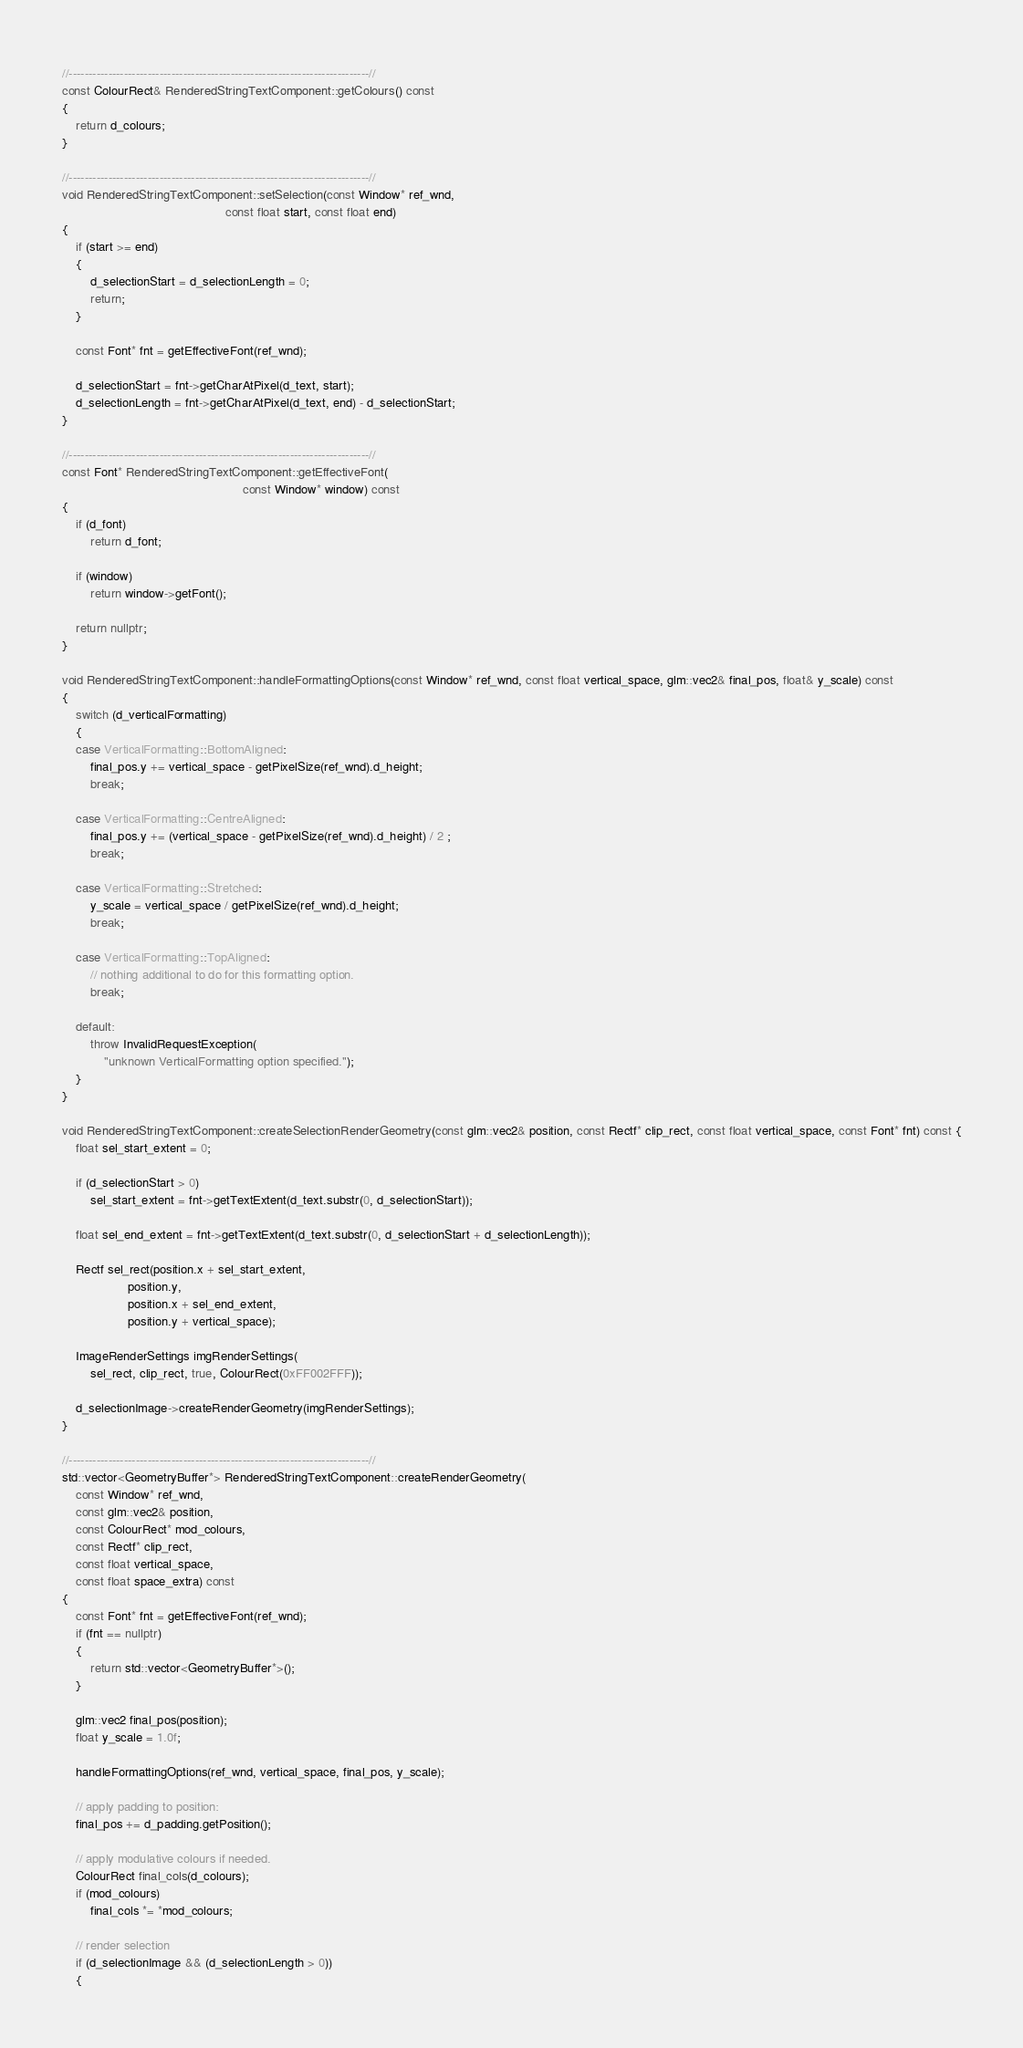Convert code to text. <code><loc_0><loc_0><loc_500><loc_500><_C++_>//----------------------------------------------------------------------------//
const ColourRect& RenderedStringTextComponent::getColours() const
{
    return d_colours;
}

//----------------------------------------------------------------------------//
void RenderedStringTextComponent::setSelection(const Window* ref_wnd,
                                               const float start, const float end)
{
    if (start >= end)
    {
        d_selectionStart = d_selectionLength = 0;
        return;
    }

    const Font* fnt = getEffectiveFont(ref_wnd);

    d_selectionStart = fnt->getCharAtPixel(d_text, start);
    d_selectionLength = fnt->getCharAtPixel(d_text, end) - d_selectionStart;
}

//----------------------------------------------------------------------------//
const Font* RenderedStringTextComponent::getEffectiveFont(
                                                    const Window* window) const
{
    if (d_font)
        return d_font;

    if (window)
        return window->getFont();

    return nullptr;
}

void RenderedStringTextComponent::handleFormattingOptions(const Window* ref_wnd, const float vertical_space, glm::vec2& final_pos, float& y_scale) const
{
    switch (d_verticalFormatting)
    {
    case VerticalFormatting::BottomAligned:
        final_pos.y += vertical_space - getPixelSize(ref_wnd).d_height;
        break;

    case VerticalFormatting::CentreAligned:
        final_pos.y += (vertical_space - getPixelSize(ref_wnd).d_height) / 2 ;
        break;

    case VerticalFormatting::Stretched:
        y_scale = vertical_space / getPixelSize(ref_wnd).d_height;
        break;

    case VerticalFormatting::TopAligned:
        // nothing additional to do for this formatting option.
        break;

    default:
        throw InvalidRequestException(
            "unknown VerticalFormatting option specified.");
    }
}

void RenderedStringTextComponent::createSelectionRenderGeometry(const glm::vec2& position, const Rectf* clip_rect, const float vertical_space, const Font* fnt) const {
    float sel_start_extent = 0;

    if (d_selectionStart > 0)
        sel_start_extent = fnt->getTextExtent(d_text.substr(0, d_selectionStart));

    float sel_end_extent = fnt->getTextExtent(d_text.substr(0, d_selectionStart + d_selectionLength));

    Rectf sel_rect(position.x + sel_start_extent,
                   position.y,
                   position.x + sel_end_extent,
                   position.y + vertical_space);

    ImageRenderSettings imgRenderSettings(
        sel_rect, clip_rect, true, ColourRect(0xFF002FFF));

    d_selectionImage->createRenderGeometry(imgRenderSettings);
}

//----------------------------------------------------------------------------//
std::vector<GeometryBuffer*> RenderedStringTextComponent::createRenderGeometry(
    const Window* ref_wnd,
    const glm::vec2& position,
    const ColourRect* mod_colours,
    const Rectf* clip_rect,
    const float vertical_space,
    const float space_extra) const
{
    const Font* fnt = getEffectiveFont(ref_wnd); 
    if (fnt == nullptr)
    {
        return std::vector<GeometryBuffer*>();
    }

    glm::vec2 final_pos(position);
    float y_scale = 1.0f;

    handleFormattingOptions(ref_wnd, vertical_space, final_pos, y_scale);

    // apply padding to position:
    final_pos += d_padding.getPosition();

    // apply modulative colours if needed.
    ColourRect final_cols(d_colours);
    if (mod_colours)
        final_cols *= *mod_colours;

    // render selection
    if (d_selectionImage && (d_selectionLength > 0))
    {</code> 